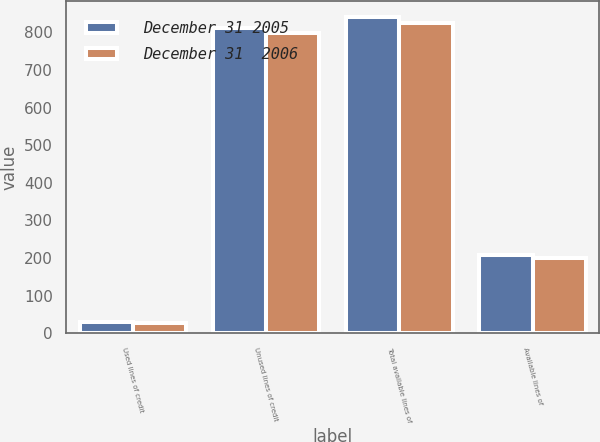<chart> <loc_0><loc_0><loc_500><loc_500><stacked_bar_chart><ecel><fcel>Used lines of credit<fcel>Unused lines of credit<fcel>Total available lines of<fcel>Available lines of<nl><fcel>December 31 2005<fcel>30.4<fcel>810.6<fcel>841<fcel>208.1<nl><fcel>December 31  2006<fcel>27.2<fcel>797.6<fcel>824.8<fcel>200.1<nl></chart> 